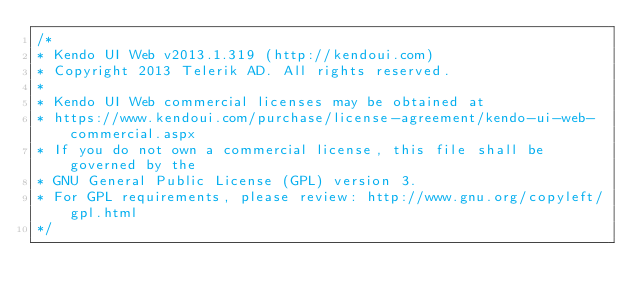<code> <loc_0><loc_0><loc_500><loc_500><_CSS_>/*
* Kendo UI Web v2013.1.319 (http://kendoui.com)
* Copyright 2013 Telerik AD. All rights reserved.
*
* Kendo UI Web commercial licenses may be obtained at
* https://www.kendoui.com/purchase/license-agreement/kendo-ui-web-commercial.aspx
* If you do not own a commercial license, this file shall be governed by the
* GNU General Public License (GPL) version 3.
* For GPL requirements, please review: http://www.gnu.org/copyleft/gpl.html
*/</code> 